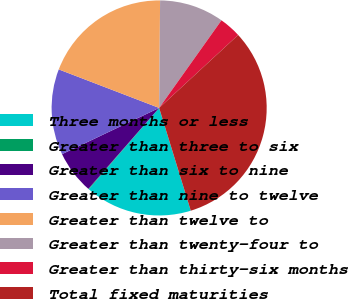Convert chart to OTSL. <chart><loc_0><loc_0><loc_500><loc_500><pie_chart><fcel>Three months or less<fcel>Greater than three to six<fcel>Greater than six to nine<fcel>Greater than nine to twelve<fcel>Greater than twelve to<fcel>Greater than twenty-four to<fcel>Greater than thirty-six months<fcel>Total fixed maturities<nl><fcel>16.1%<fcel>0.09%<fcel>6.49%<fcel>12.9%<fcel>19.31%<fcel>9.7%<fcel>3.29%<fcel>32.12%<nl></chart> 